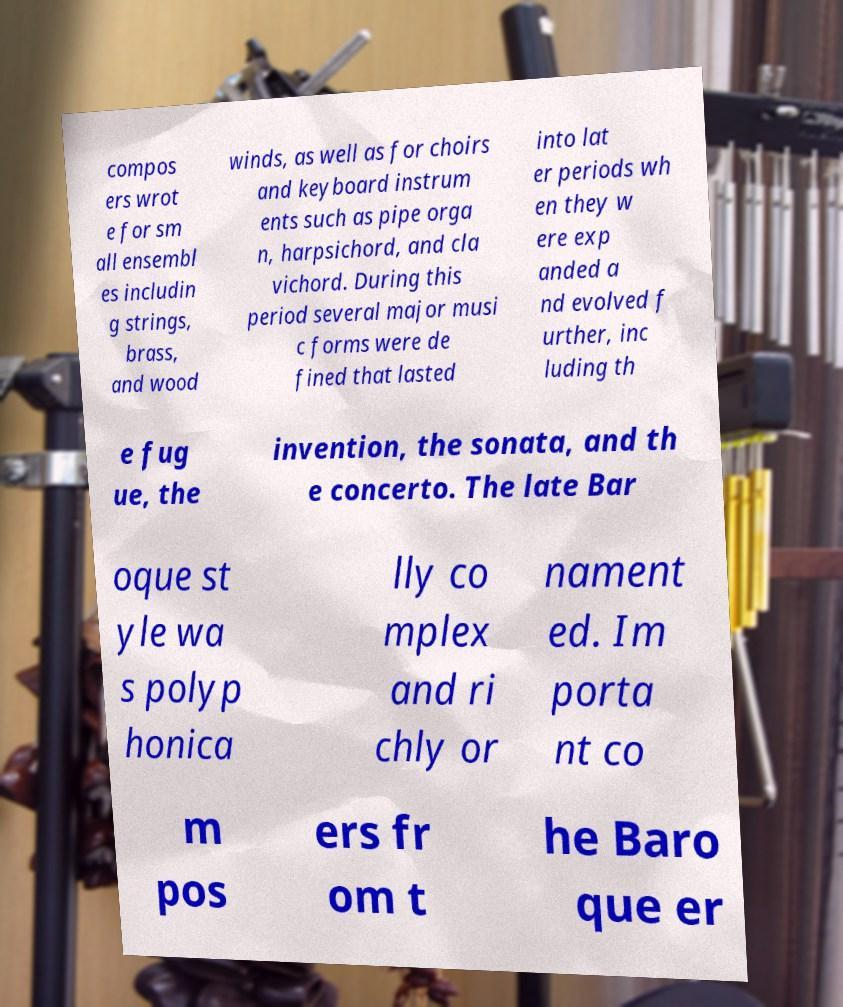Could you assist in decoding the text presented in this image and type it out clearly? compos ers wrot e for sm all ensembl es includin g strings, brass, and wood winds, as well as for choirs and keyboard instrum ents such as pipe orga n, harpsichord, and cla vichord. During this period several major musi c forms were de fined that lasted into lat er periods wh en they w ere exp anded a nd evolved f urther, inc luding th e fug ue, the invention, the sonata, and th e concerto. The late Bar oque st yle wa s polyp honica lly co mplex and ri chly or nament ed. Im porta nt co m pos ers fr om t he Baro que er 